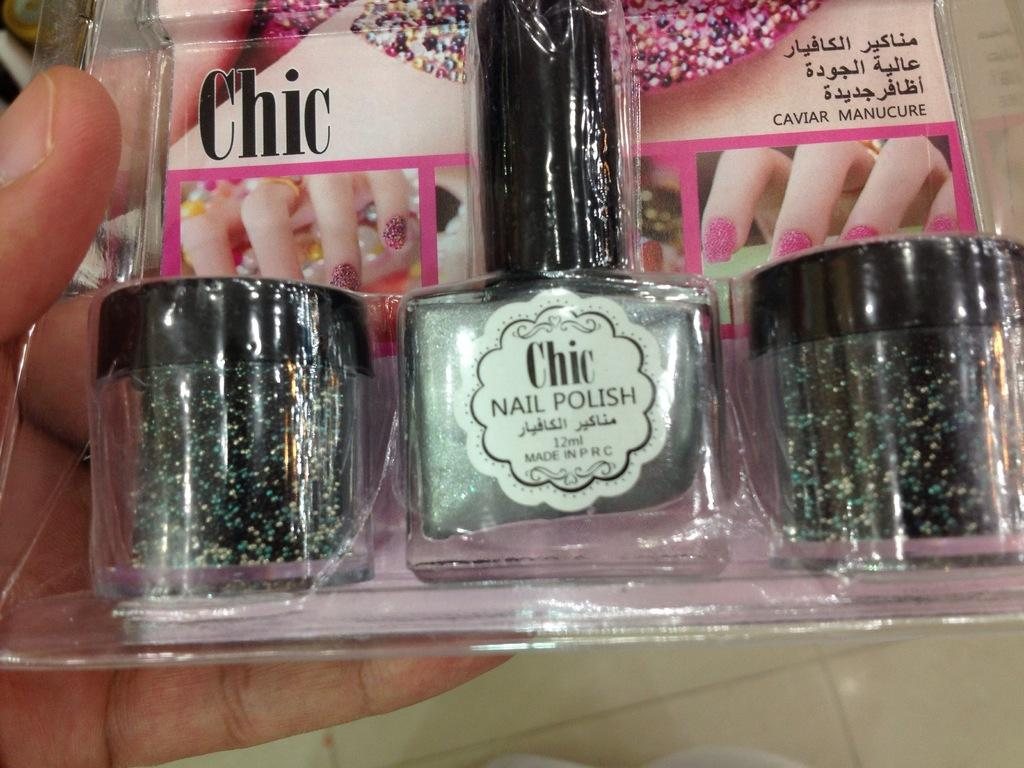<image>
Relay a brief, clear account of the picture shown. A package has a bottle of Chic brand nail polish in it. 